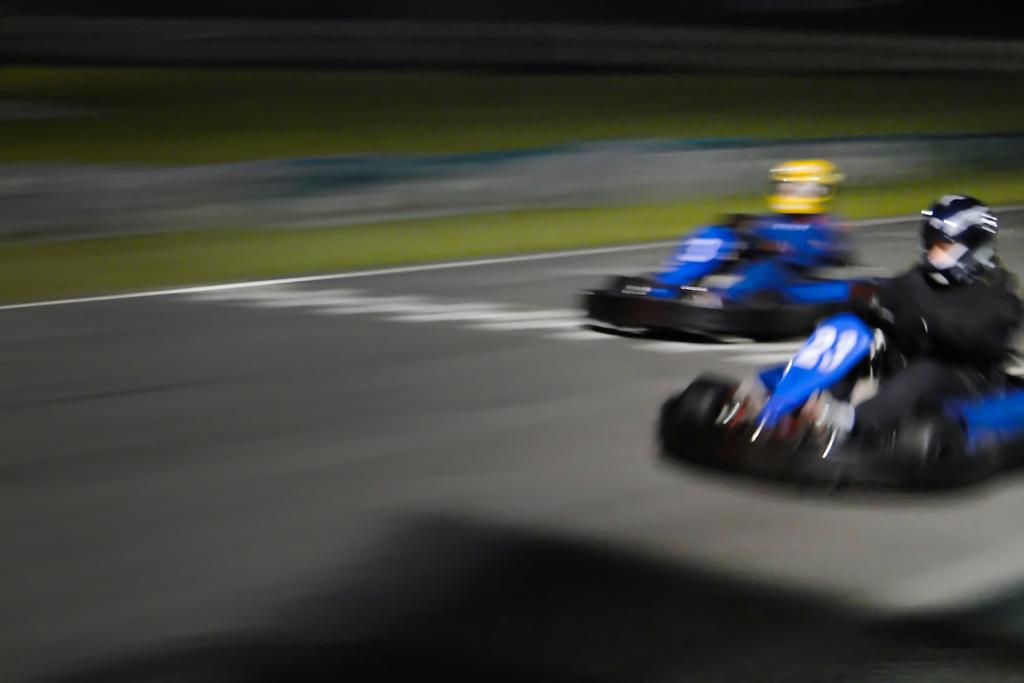How many people are in the image? There are two persons in the image. What are the persons doing in the image? The persons are riding cars. Where are the cars located in the image? The cars are on a road. Which side of the image shows the road? The road is visible on the right side of the image. What type of feast is being prepared on the bridge in the image? There is no bridge or feast present in the image; it features two persons riding cars on a road. What kind of apparatus is being used by the persons in the image? There is no apparatus visible in the image; the persons are simply riding cars. 